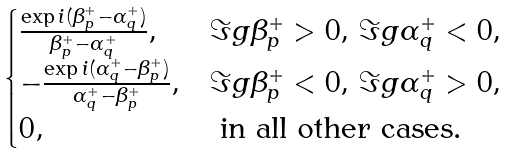Convert formula to latex. <formula><loc_0><loc_0><loc_500><loc_500>\begin{cases} \frac { \exp i ( \beta _ { p } ^ { + } - \alpha _ { q } ^ { + } ) } { \beta _ { p } ^ { + } - \alpha _ { q } ^ { + } } , & \Im g \beta _ { p } ^ { + } > 0 , \, \Im g \alpha _ { q } ^ { + } < 0 , \\ - \frac { \exp i ( \alpha _ { q } ^ { + } - \beta _ { p } ^ { + } ) } { \alpha _ { q } ^ { + } - \beta _ { p } ^ { + } } , & \Im g \beta _ { p } ^ { + } < 0 , \, \Im g \alpha _ { q } ^ { + } > 0 , \\ 0 , & \text { in all other cases} . \end{cases}</formula> 